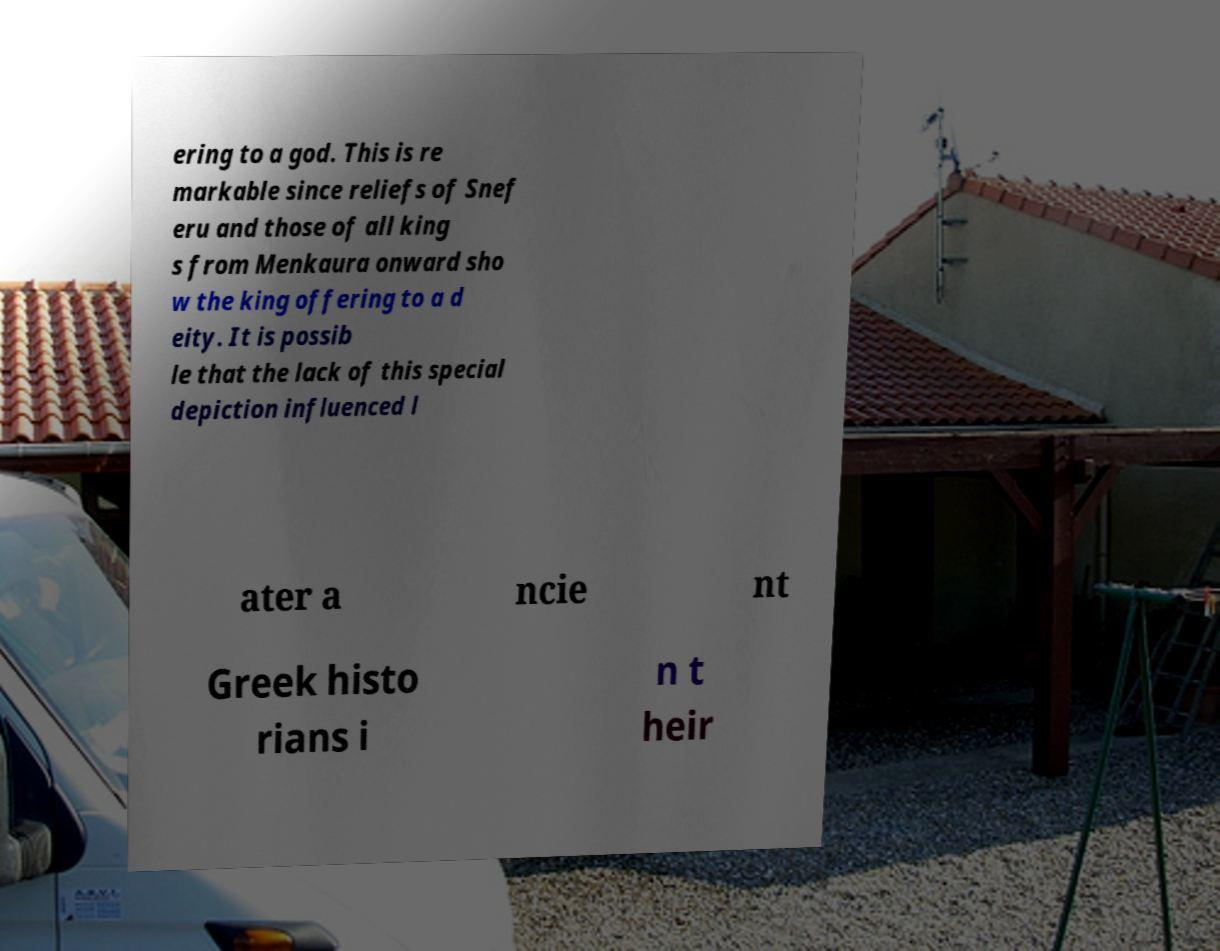Could you extract and type out the text from this image? ering to a god. This is re markable since reliefs of Snef eru and those of all king s from Menkaura onward sho w the king offering to a d eity. It is possib le that the lack of this special depiction influenced l ater a ncie nt Greek histo rians i n t heir 